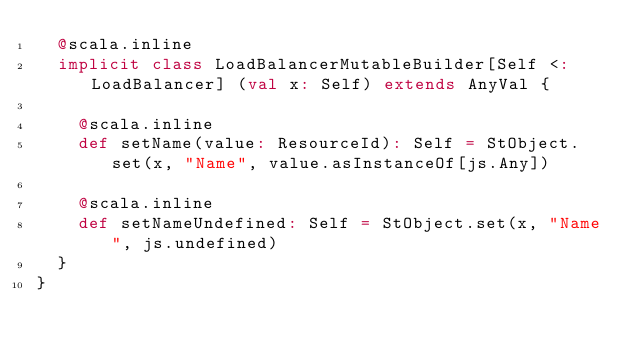<code> <loc_0><loc_0><loc_500><loc_500><_Scala_>  @scala.inline
  implicit class LoadBalancerMutableBuilder[Self <: LoadBalancer] (val x: Self) extends AnyVal {
    
    @scala.inline
    def setName(value: ResourceId): Self = StObject.set(x, "Name", value.asInstanceOf[js.Any])
    
    @scala.inline
    def setNameUndefined: Self = StObject.set(x, "Name", js.undefined)
  }
}
</code> 